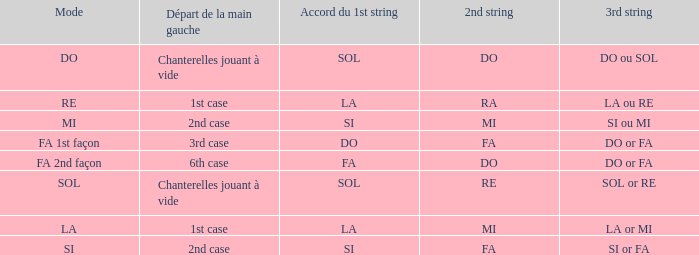What is the technique of the depart de la main gauche of 1st instance and a la or mi 3rd string? LA. Could you parse the entire table as a dict? {'header': ['Mode', 'Départ de la main gauche', 'Accord du 1st string', '2nd string', '3rd string'], 'rows': [['DO', 'Chanterelles jouant à vide', 'SOL', 'DO', 'DO ou SOL'], ['RE', '1st case', 'LA', 'RA', 'LA ou RE'], ['MI', '2nd case', 'SI', 'MI', 'SI ou MI'], ['FA 1st façon', '3rd case', 'DO', 'FA', 'DO or FA'], ['FA 2nd façon', '6th case', 'FA', 'DO', 'DO or FA'], ['SOL', 'Chanterelles jouant à vide', 'SOL', 'RE', 'SOL or RE'], ['LA', '1st case', 'LA', 'MI', 'LA or MI'], ['SI', '2nd case', 'SI', 'FA', 'SI or FA']]} 